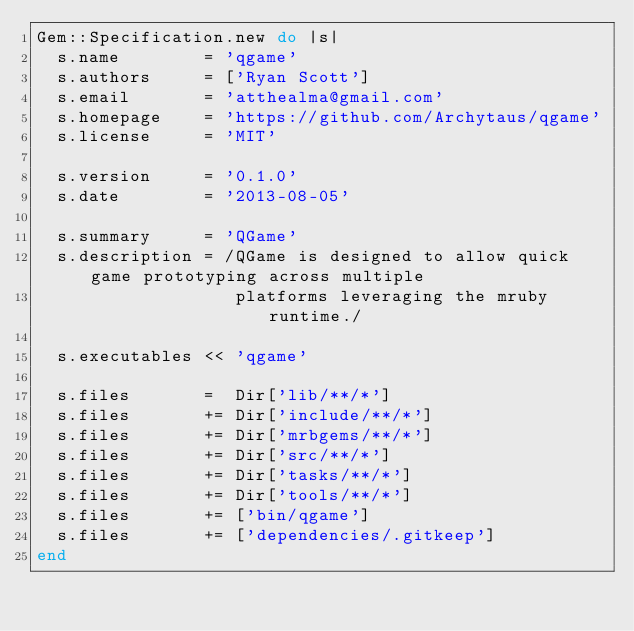Convert code to text. <code><loc_0><loc_0><loc_500><loc_500><_Ruby_>Gem::Specification.new do |s|
  s.name        = 'qgame'
  s.authors     = ['Ryan Scott']
  s.email       = 'atthealma@gmail.com'
  s.homepage    = 'https://github.com/Archytaus/qgame'
  s.license     = 'MIT'

  s.version     = '0.1.0'
  s.date        = '2013-08-05'

  s.summary     = 'QGame'
  s.description = /QGame is designed to allow quick game prototyping across multiple
                   platforms leveraging the mruby runtime./

  s.executables << 'qgame'

  s.files       =  Dir['lib/**/*']
  s.files       += Dir['include/**/*']
  s.files       += Dir['mrbgems/**/*']
  s.files       += Dir['src/**/*']
  s.files       += Dir['tasks/**/*']
  s.files       += Dir['tools/**/*']
  s.files       += ['bin/qgame']
  s.files       += ['dependencies/.gitkeep']
end</code> 